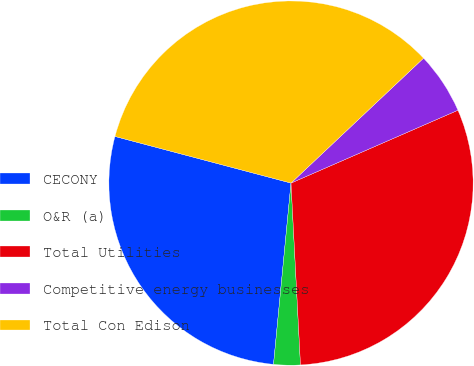Convert chart. <chart><loc_0><loc_0><loc_500><loc_500><pie_chart><fcel>CECONY<fcel>O&R (a)<fcel>Total Utilities<fcel>Competitive energy businesses<fcel>Total Con Edison<nl><fcel>27.59%<fcel>2.36%<fcel>30.72%<fcel>5.48%<fcel>33.85%<nl></chart> 